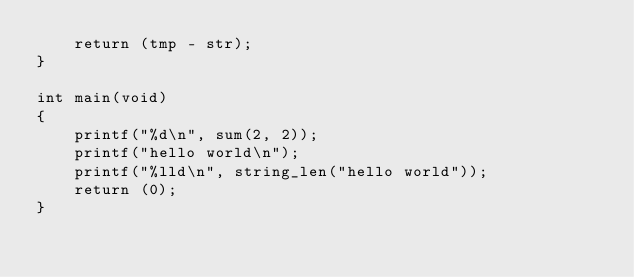<code> <loc_0><loc_0><loc_500><loc_500><_C_>    return (tmp - str);
}

int main(void)
{
    printf("%d\n", sum(2, 2));
    printf("hello world\n");
    printf("%lld\n", string_len("hello world"));
    return (0);
}</code> 